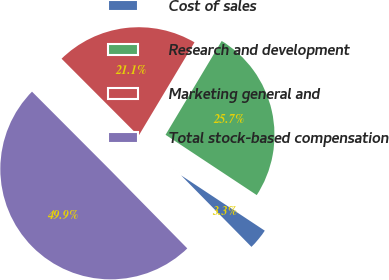Convert chart to OTSL. <chart><loc_0><loc_0><loc_500><loc_500><pie_chart><fcel>Cost of sales<fcel>Research and development<fcel>Marketing general and<fcel>Total stock-based compensation<nl><fcel>3.33%<fcel>25.72%<fcel>21.06%<fcel>49.89%<nl></chart> 